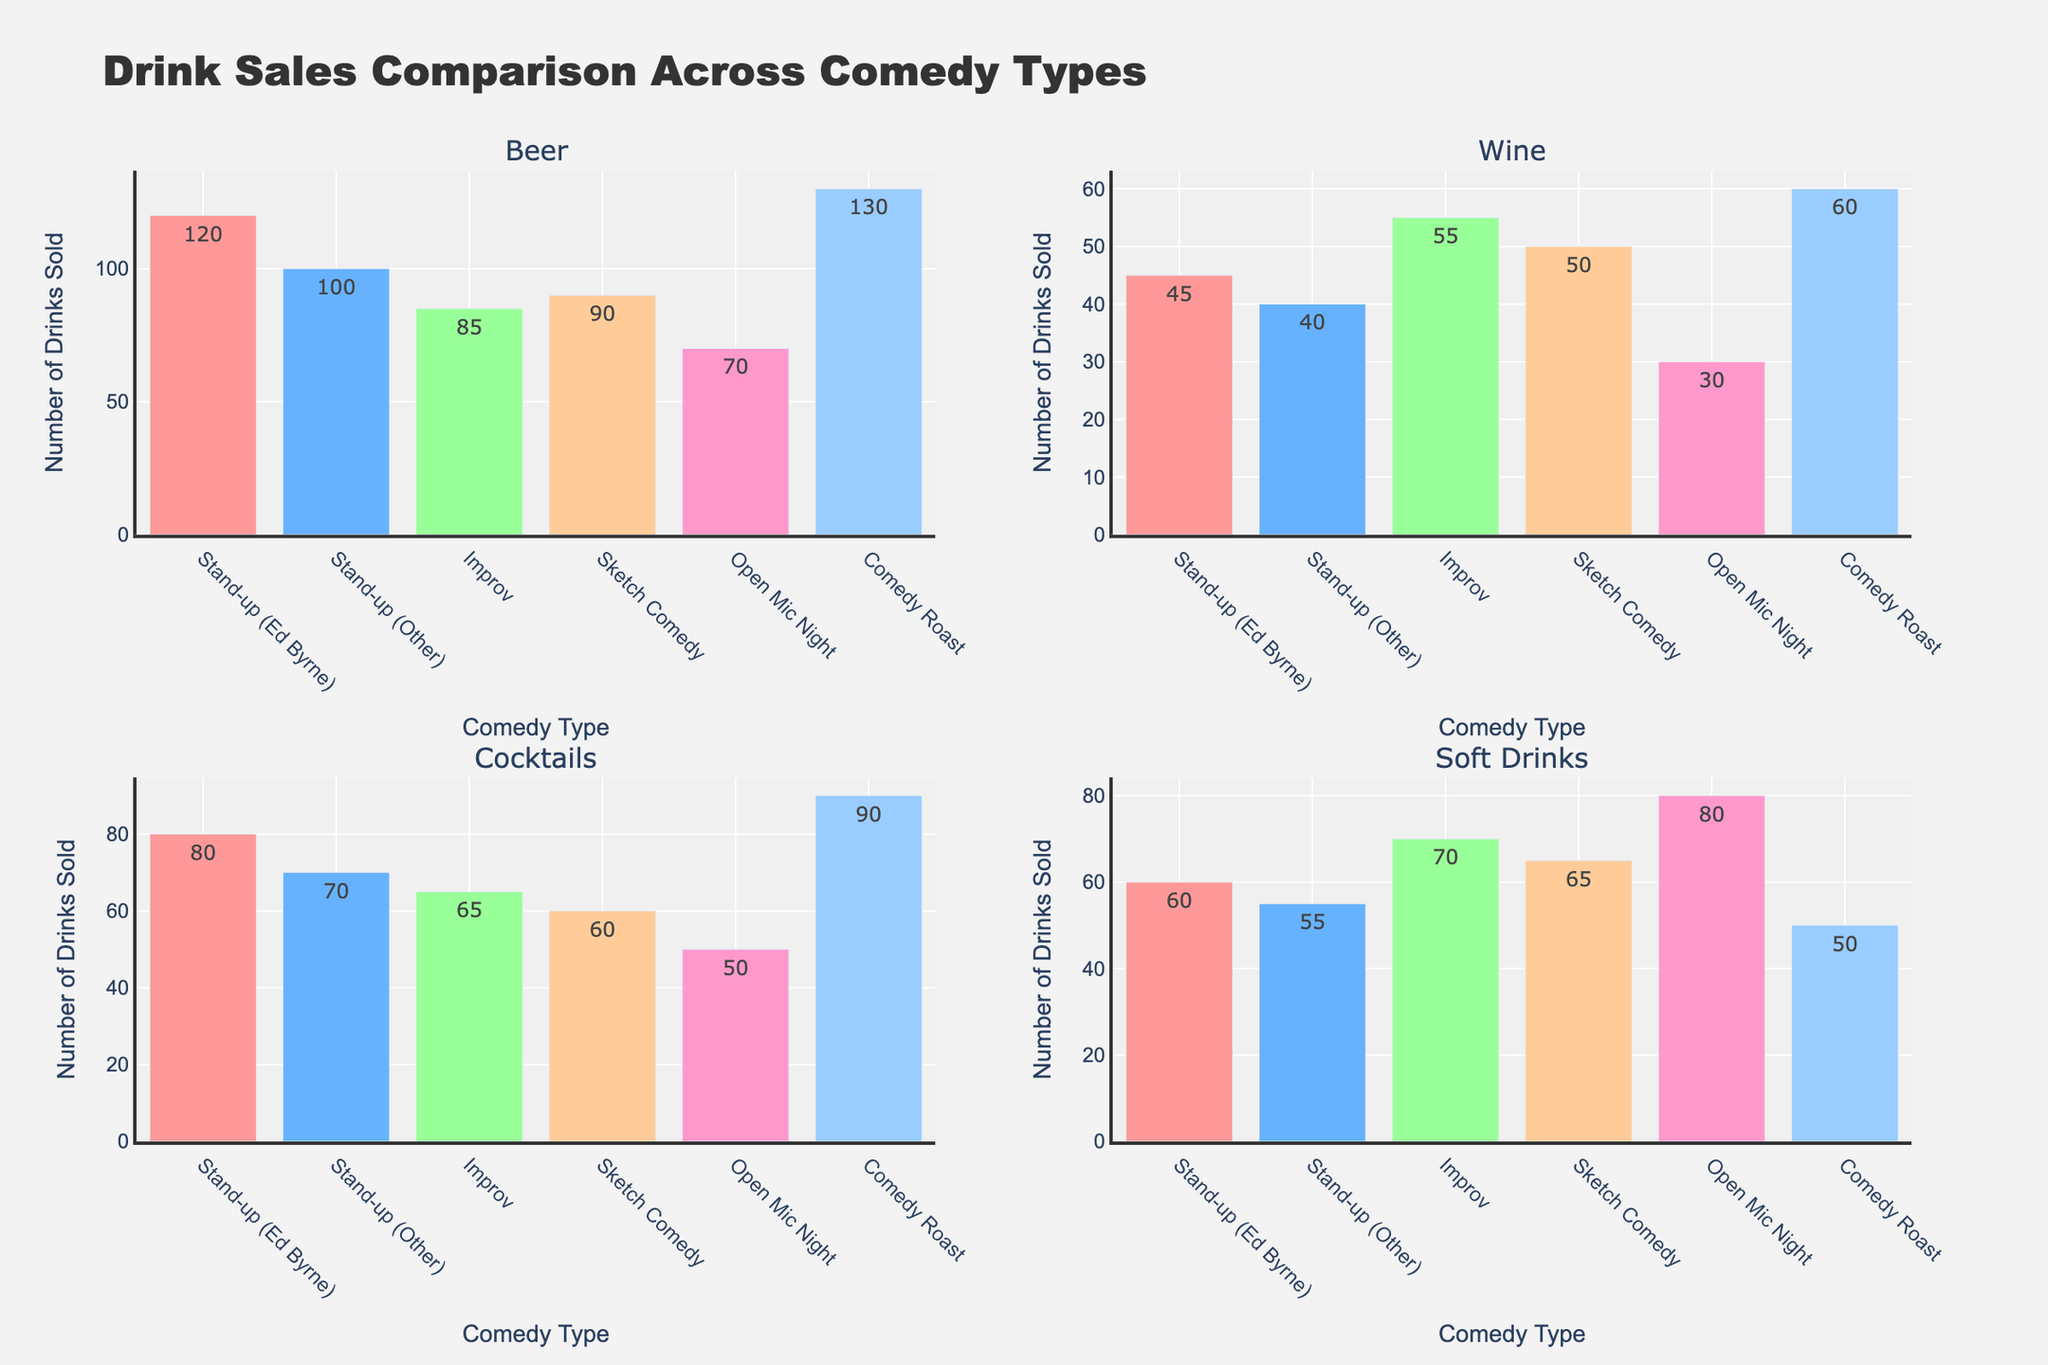What is the title of the figure? The title is found at the top of the figure and it usually summarizes the content of the figure. In this case, it reads "Drink Sales Comparison Across Comedy Types."
Answer: Drink Sales Comparison Across Comedy Types Which type of comedy act had the highest sale of beer? Look at the Beer subplot and find the comedy act with the tallest bar. The tallest bar corresponds to "Comedy Roast" with a sale of 130 beers.
Answer: Comedy Roast How many types of drinks are compared in the figure? The figure consists of four subplots: Beer, Wine, Cocktails, and Soft Drinks, each representing a different type of drink.
Answer: 4 Which type of comedy act had the least sale of soft drinks? Look at the Soft Drinks subplot and identify the shortest bar. The shortest bar corresponds to "Comedy Roast" with 50 soft drinks sold.
Answer: Comedy Roast What is the total number of beers sold during stand-up comedy acts (Ed Byrne and Other combined)? Sum the values of beers sold during "Stand-up (Ed Byrne)" and "Stand-up (Other). The values are 120 (Ed Byrne) and 100 (Other). Sum = 120 + 100.
Answer: 220 In which subplot do we see the highest variability in drink sales across comedy types? Compare the variabilities in the heights of the bars across the four subplots. Beer has the highest variability (ranging from 70 to 130).
Answer: Beer Which type of drink is sold the most during Sketch Comedy acts? Compare the heights of the bars in the Sketch Comedy column across all subplots. The tallest bar is in the Soft Drinks subplot with 65 drinks sold.
Answer: Soft Drinks What is the combined total sale of cocktails and wine during Improv acts? Sum the number of cocktails and wine sold during Improv acts. The values are 65 (Cocktails) and 55 (Wine). Sum = 65 + 55.
Answer: 120 Which comedy act sees higher sales of soft drinks than cocktails? For each comedy act, compare the value of soft drinks to that of cocktails. "Improv," "Sketch Comedy," and "Open Mic Night" have higher soft drink sales compared to cocktails.
Answer: Improv, Sketch Comedy, Open Mic Night Which comedy act had the second-highest sale of wine? Look for the Wine subplot and identify the bar with the second-highest value. The second-highest value for wine corresponds to "Comedy Roast" with 60 wines sold.
Answer: Comedy Roast 